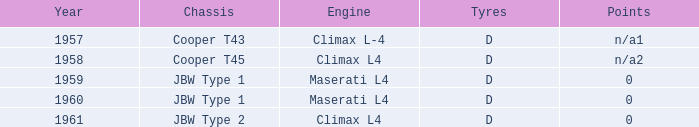What is the tyres with a year earlier than 1961 for a climax l4 engine? D. 